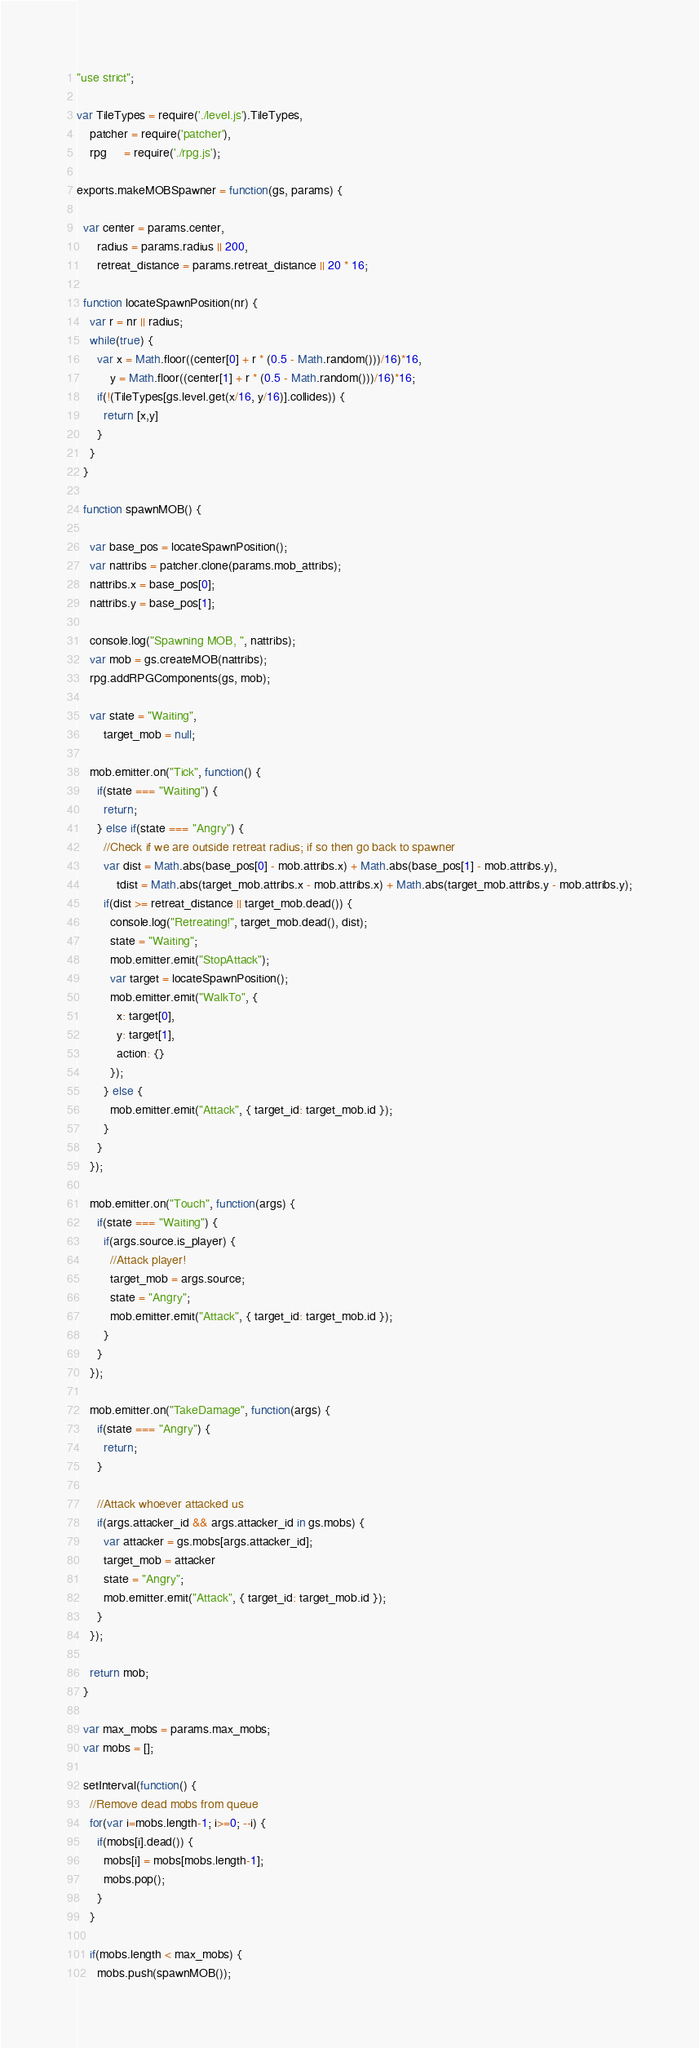Convert code to text. <code><loc_0><loc_0><loc_500><loc_500><_JavaScript_>"use strict";

var TileTypes = require('./level.js').TileTypes,
    patcher = require('patcher'),
    rpg     = require('./rpg.js');

exports.makeMOBSpawner = function(gs, params) {

  var center = params.center,
      radius = params.radius || 200,
      retreat_distance = params.retreat_distance || 20 * 16;

  function locateSpawnPosition(nr) {
    var r = nr || radius;
    while(true) {
      var x = Math.floor((center[0] + r * (0.5 - Math.random()))/16)*16,
          y = Math.floor((center[1] + r * (0.5 - Math.random()))/16)*16;
      if(!(TileTypes[gs.level.get(x/16, y/16)].collides)) {
        return [x,y]
      }
    }
  }

  function spawnMOB() {
  
    var base_pos = locateSpawnPosition();
    var nattribs = patcher.clone(params.mob_attribs);
    nattribs.x = base_pos[0];
    nattribs.y = base_pos[1];
    
    console.log("Spawning MOB, ", nattribs);
    var mob = gs.createMOB(nattribs);
    rpg.addRPGComponents(gs, mob);

    var state = "Waiting",
        target_mob = null;

    mob.emitter.on("Tick", function() {
      if(state === "Waiting") {
        return;
      } else if(state === "Angry") {
        //Check if we are outside retreat radius; if so then go back to spawner
        var dist = Math.abs(base_pos[0] - mob.attribs.x) + Math.abs(base_pos[1] - mob.attribs.y),
            tdist = Math.abs(target_mob.attribs.x - mob.attribs.x) + Math.abs(target_mob.attribs.y - mob.attribs.y);
        if(dist >= retreat_distance || target_mob.dead()) {
          console.log("Retreating!", target_mob.dead(), dist);
          state = "Waiting";
          mob.emitter.emit("StopAttack");
          var target = locateSpawnPosition();
          mob.emitter.emit("WalkTo", {
            x: target[0],
            y: target[1],
            action: {}
          });
        } else {
          mob.emitter.emit("Attack", { target_id: target_mob.id });
        }
      } 
    });

    mob.emitter.on("Touch", function(args) {
      if(state === "Waiting") {
        if(args.source.is_player) {
          //Attack player!
          target_mob = args.source;
          state = "Angry";
          mob.emitter.emit("Attack", { target_id: target_mob.id });
        }
      }    
    });
    
    mob.emitter.on("TakeDamage", function(args) {
      if(state === "Angry") {
        return;
      }
      
      //Attack whoever attacked us
      if(args.attacker_id && args.attacker_id in gs.mobs) {
        var attacker = gs.mobs[args.attacker_id];
        target_mob = attacker
        state = "Angry";
        mob.emitter.emit("Attack", { target_id: target_mob.id });
      }
    });
    
    return mob;
  }

  var max_mobs = params.max_mobs;
  var mobs = [];
  
  setInterval(function() {
    //Remove dead mobs from queue
    for(var i=mobs.length-1; i>=0; --i) {
      if(mobs[i].dead()) {
        mobs[i] = mobs[mobs.length-1];
        mobs.pop();
      }
    }
  
    if(mobs.length < max_mobs) {
      mobs.push(spawnMOB());</code> 